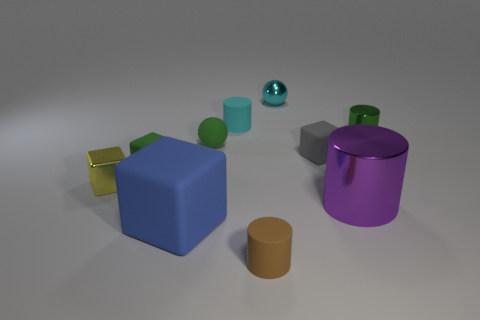Is the color of the large rubber object the same as the shiny sphere?
Your answer should be compact. No. How many objects are in front of the yellow block and to the right of the brown rubber cylinder?
Provide a short and direct response. 1. How many tiny cyan metallic objects have the same shape as the brown object?
Ensure brevity in your answer.  0. Is the material of the big purple object the same as the yellow cube?
Provide a succinct answer. Yes. What is the shape of the tiny green matte thing that is on the right side of the green rubber thing on the left side of the large matte cube?
Provide a short and direct response. Sphere. There is a green thing to the right of the brown object; what number of matte things are in front of it?
Ensure brevity in your answer.  5. What is the material of the small object that is left of the purple cylinder and to the right of the cyan metallic ball?
Keep it short and to the point. Rubber. The cyan matte thing that is the same size as the gray block is what shape?
Ensure brevity in your answer.  Cylinder. There is a small metal thing that is to the left of the rubber block in front of the green block that is to the left of the brown thing; what is its color?
Your response must be concise. Yellow. How many things are blocks that are behind the big purple shiny object or green rubber objects?
Provide a short and direct response. 4. 